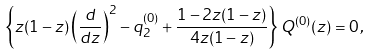Convert formula to latex. <formula><loc_0><loc_0><loc_500><loc_500>\left \{ z ( 1 - z ) \left ( \frac { d } { d z } \right ) ^ { 2 } - q _ { 2 } ^ { ( 0 ) } + \frac { 1 - 2 z ( 1 - z ) } { 4 z ( 1 - z ) } \right \} Q ^ { ( 0 ) } ( z ) = 0 \, ,</formula> 